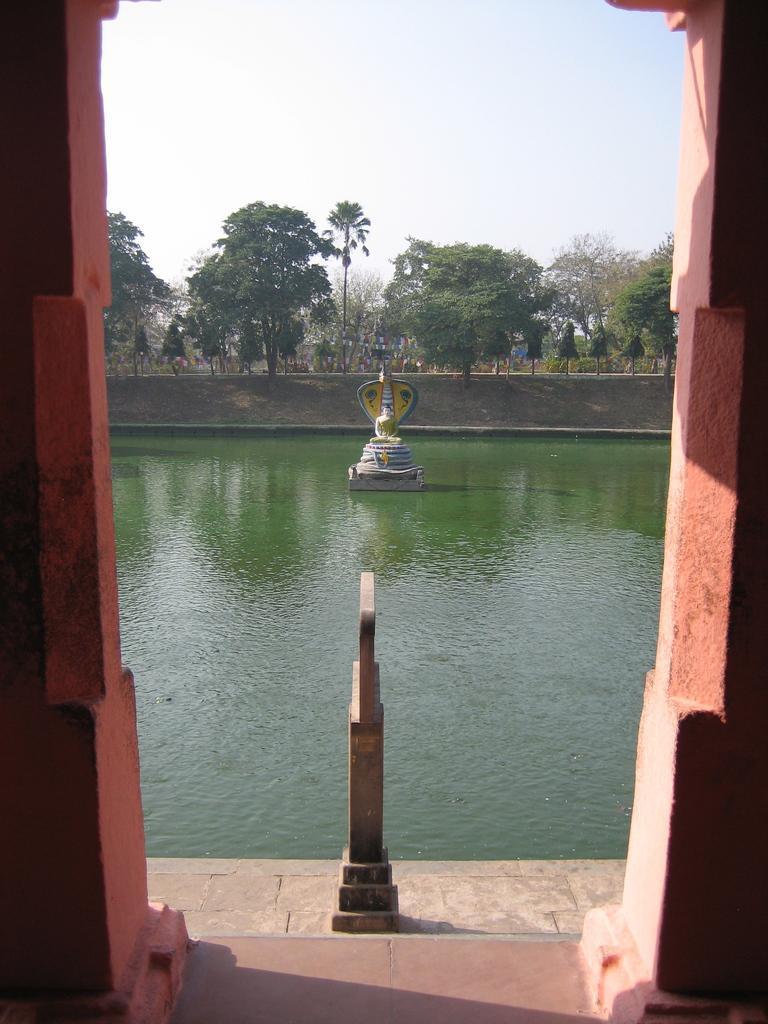How would you summarize this image in a sentence or two? In this picture we can see concrete snake design in the water. On the left and right side we can see pillars, beside that there are stairs. In the background we can see many trees, plants and grass. At the top there is a sky. 